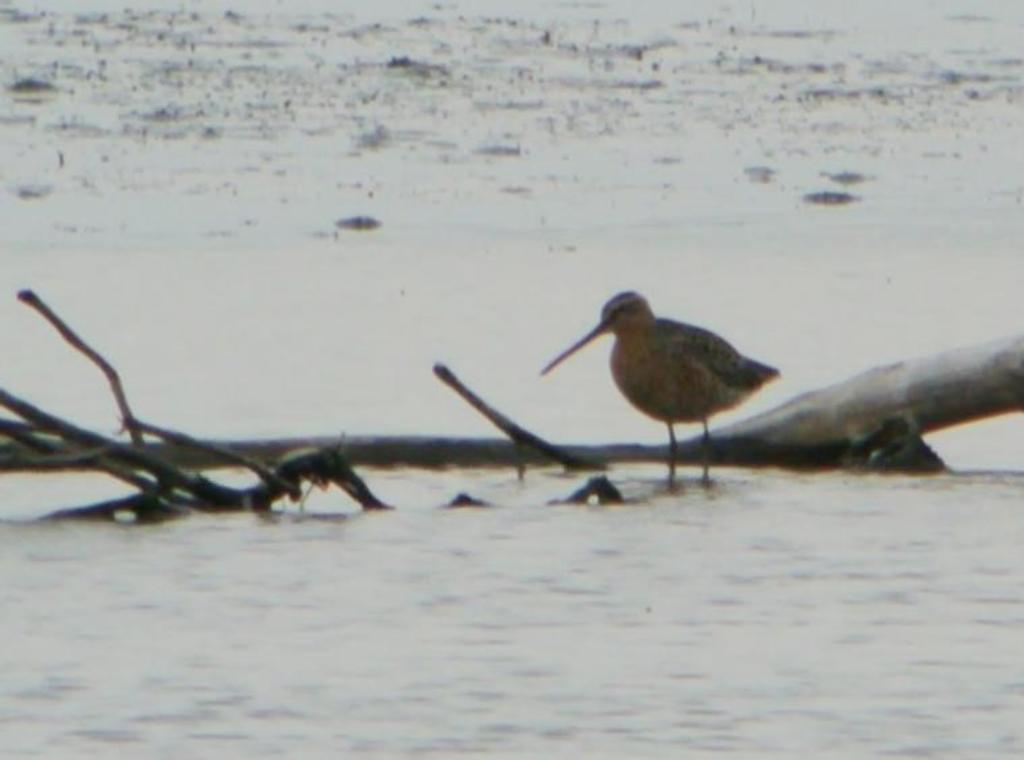What type of animal is in the image? There is a bird in the image. What is the bird doing in the image? The bird is standing on the water. What type of rake is being used to create the design on the boats in the image? There are no boats or rakes present in the image; it features a bird standing on the water. 